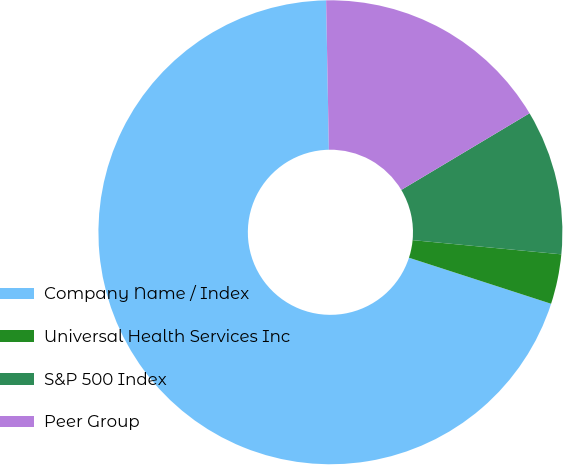Convert chart to OTSL. <chart><loc_0><loc_0><loc_500><loc_500><pie_chart><fcel>Company Name / Index<fcel>Universal Health Services Inc<fcel>S&P 500 Index<fcel>Peer Group<nl><fcel>69.72%<fcel>3.47%<fcel>10.09%<fcel>16.72%<nl></chart> 